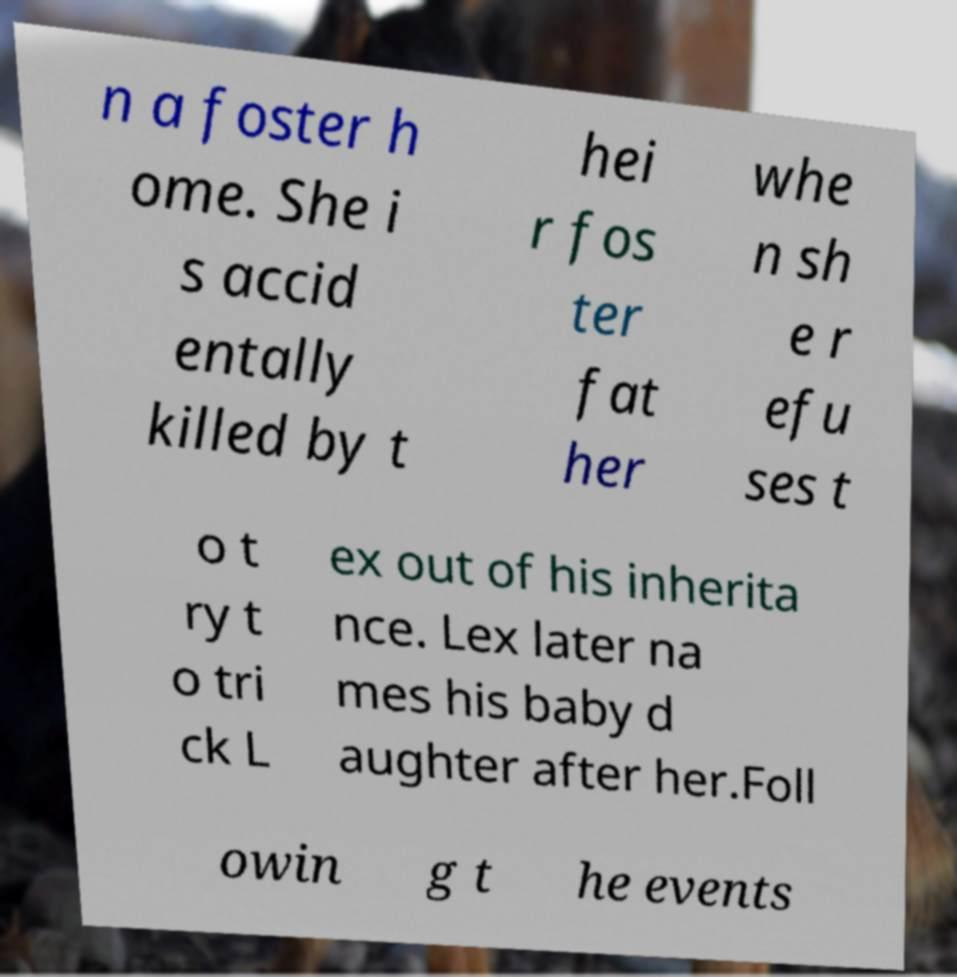What messages or text are displayed in this image? I need them in a readable, typed format. n a foster h ome. She i s accid entally killed by t hei r fos ter fat her whe n sh e r efu ses t o t ry t o tri ck L ex out of his inherita nce. Lex later na mes his baby d aughter after her.Foll owin g t he events 